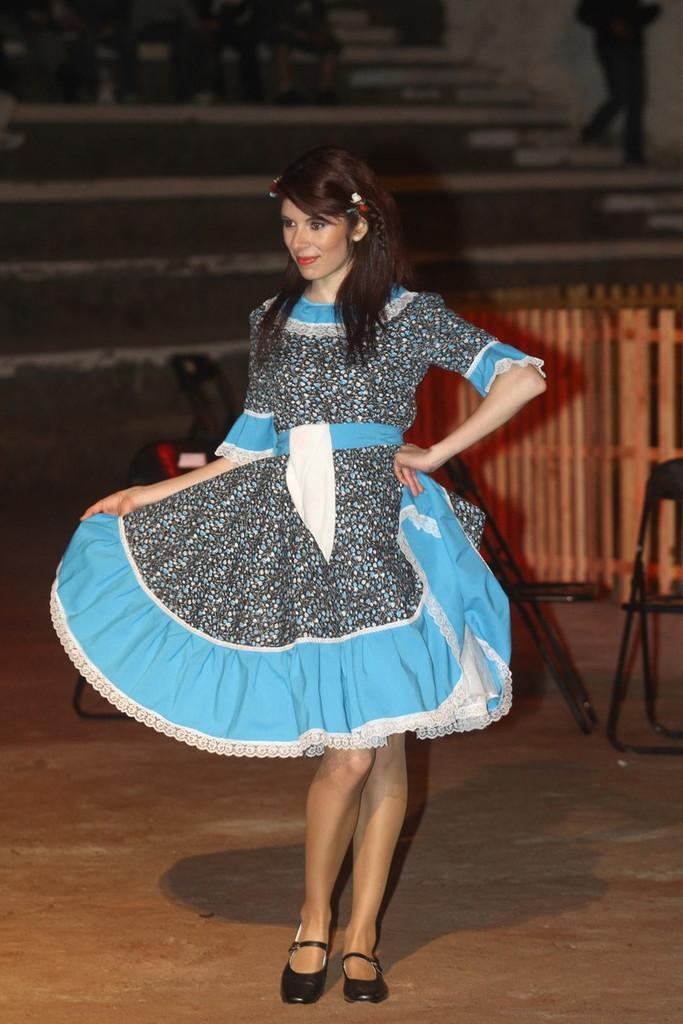In one or two sentences, can you explain what this image depicts? In this image we can see there is a girl and looking to the left side of the image, behind her there are two chairs and a wooden fence. 